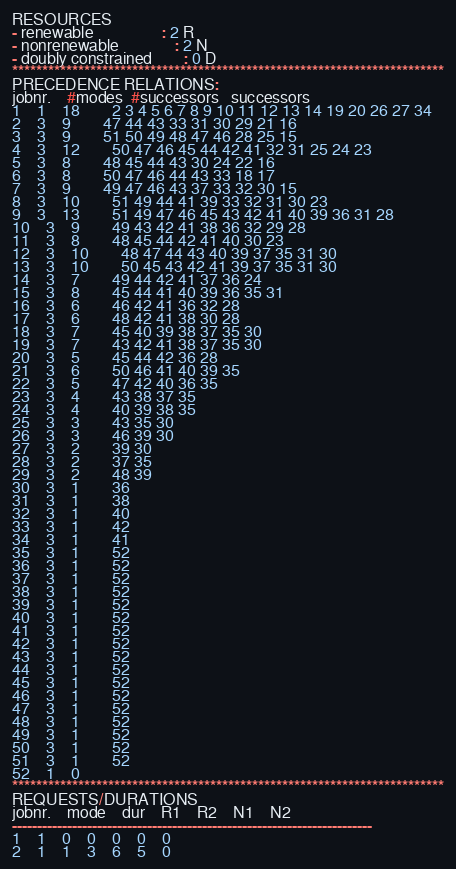<code> <loc_0><loc_0><loc_500><loc_500><_ObjectiveC_>RESOURCES
- renewable                 : 2 R
- nonrenewable              : 2 N
- doubly constrained        : 0 D
************************************************************************
PRECEDENCE RELATIONS:
jobnr.    #modes  #successors   successors
1	1	18		2 3 4 5 6 7 8 9 10 11 12 13 14 19 20 26 27 34 
2	3	9		47 44 43 33 31 30 29 21 16 
3	3	9		51 50 49 48 47 46 28 25 15 
4	3	12		50 47 46 45 44 42 41 32 31 25 24 23 
5	3	8		48 45 44 43 30 24 22 16 
6	3	8		50 47 46 44 43 33 18 17 
7	3	9		49 47 46 43 37 33 32 30 15 
8	3	10		51 49 44 41 39 33 32 31 30 23 
9	3	13		51 49 47 46 45 43 42 41 40 39 36 31 28 
10	3	9		49 43 42 41 38 36 32 29 28 
11	3	8		48 45 44 42 41 40 30 23 
12	3	10		48 47 44 43 40 39 37 35 31 30 
13	3	10		50 45 43 42 41 39 37 35 31 30 
14	3	7		49 44 42 41 37 36 24 
15	3	8		45 44 41 40 39 36 35 31 
16	3	6		46 42 41 36 32 28 
17	3	6		48 42 41 38 30 28 
18	3	7		45 40 39 38 37 35 30 
19	3	7		43 42 41 38 37 35 30 
20	3	5		45 44 42 36 28 
21	3	6		50 46 41 40 39 35 
22	3	5		47 42 40 36 35 
23	3	4		43 38 37 35 
24	3	4		40 39 38 35 
25	3	3		43 35 30 
26	3	3		46 39 30 
27	3	2		39 30 
28	3	2		37 35 
29	3	2		48 39 
30	3	1		36 
31	3	1		38 
32	3	1		40 
33	3	1		42 
34	3	1		41 
35	3	1		52 
36	3	1		52 
37	3	1		52 
38	3	1		52 
39	3	1		52 
40	3	1		52 
41	3	1		52 
42	3	1		52 
43	3	1		52 
44	3	1		52 
45	3	1		52 
46	3	1		52 
47	3	1		52 
48	3	1		52 
49	3	1		52 
50	3	1		52 
51	3	1		52 
52	1	0		
************************************************************************
REQUESTS/DURATIONS
jobnr.	mode	dur	R1	R2	N1	N2	
------------------------------------------------------------------------
1	1	0	0	0	0	0	
2	1	1	3	6	5	0	</code> 